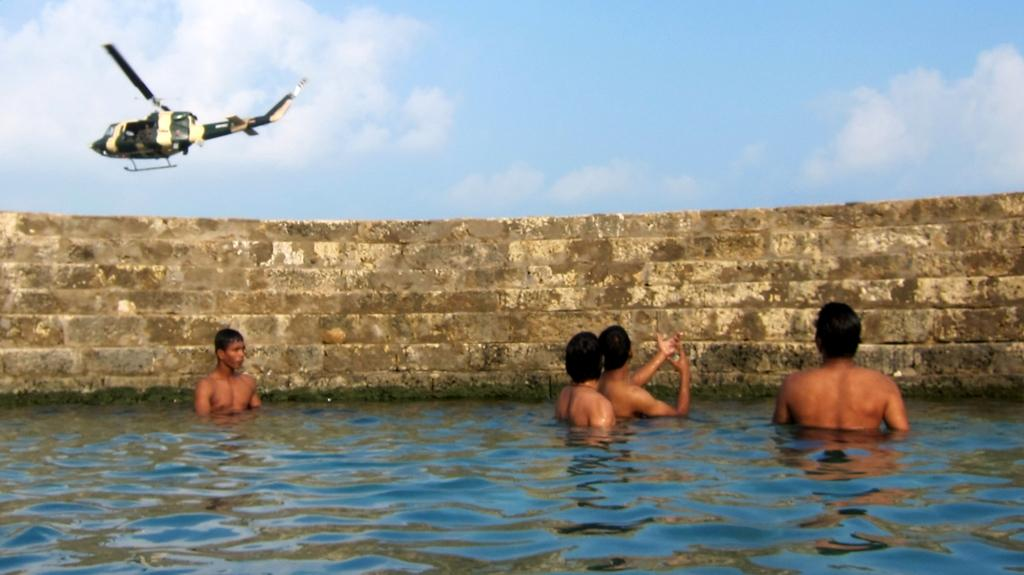How many people are in the water in the image? There are four people in the water in the image. What can be seen in the background of the image? There is a wall visible in the image. What is flying in the air in the image? An aeroplane is flying in the air in the image. What colors are present in the sky in the image? The sky is a combination of white and blue colors in the image. What type of disease is affecting the people in the water in the image? There is no indication of any disease affecting the people in the water in the image. What is the weight of the aeroplane flying in the air in the image? The weight of the aeroplane cannot be determined from the image alone. 